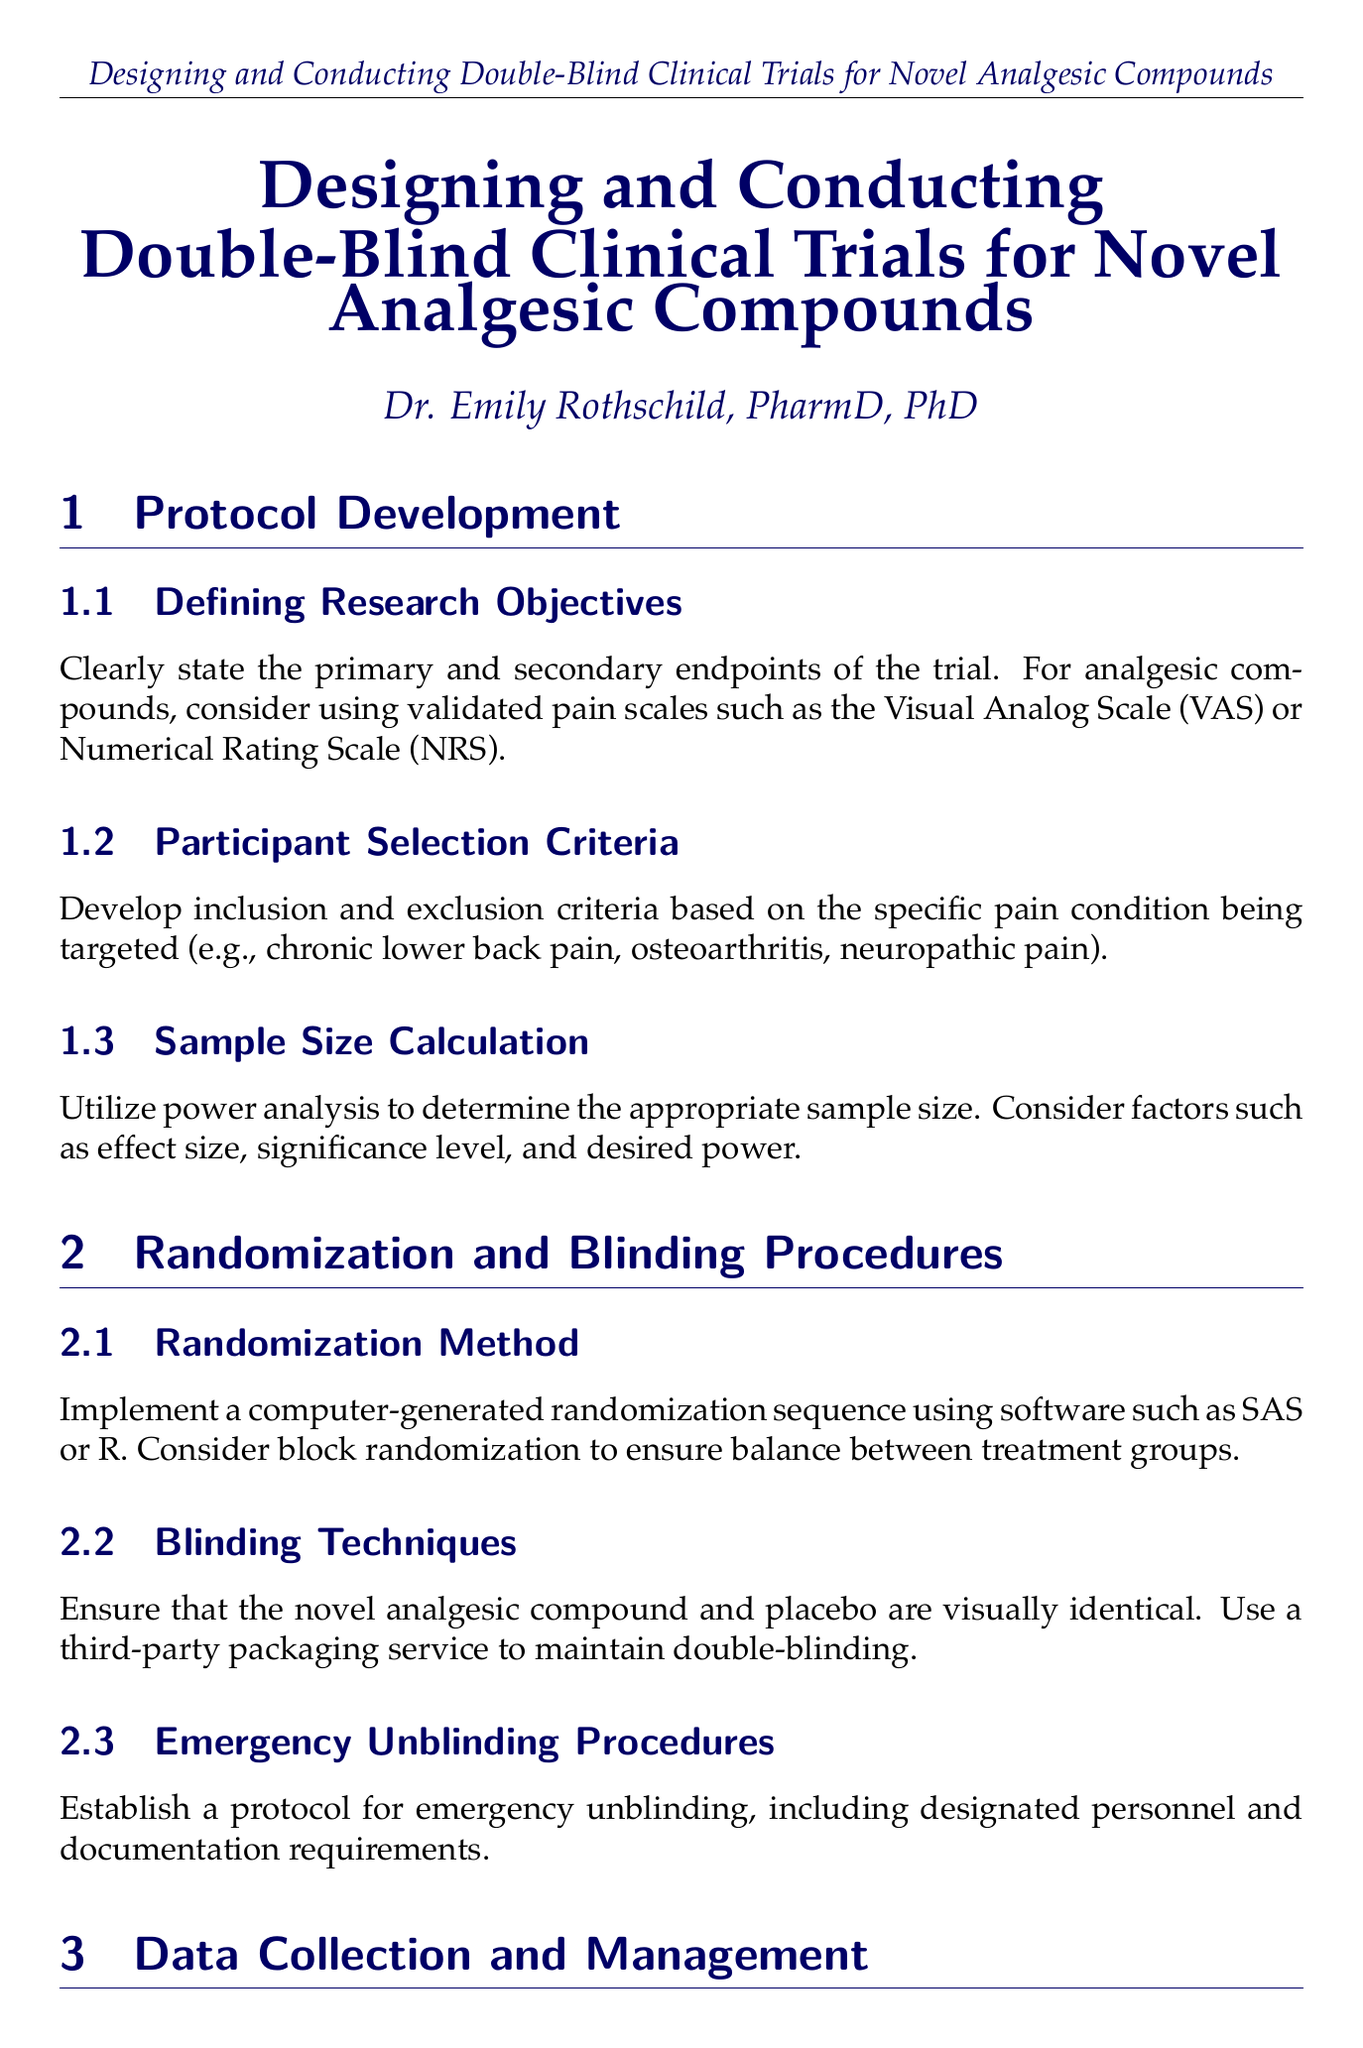what is the title of the manual? The title is stated clearly at the beginning of the document.
Answer: Designing and Conducting Double-Blind Clinical Trials for Novel Analgesic Compounds who is the author of the manual? The author is mentioned just below the title in the document.
Answer: Dr. Emily Rothschild, PharmD, PhD what is a validated pain scale mentioned in the protocol development section? The document provides examples of validated pain scales in the content under protocol development.
Answer: Visual Analog Scale what is the purpose of the Data Safety Monitoring Board? The function is outlined in the study conduct and monitoring section of the document.
Answer: Regularly review safety data which statistical method is suggested for analyzing the primary endpoint? The suggested statistical methods are specified in the statistical analysis plan section of the document.
Answer: Repeated measures ANOVA what should the informed consent form comply with? This requirement is detailed in the ethical considerations section of the document.
Answer: ICH-GCP guidelines what is the focus of the second appendix? The content of the second appendix is indicated explicitly in the document.
Answer: Pain Assessment Tools 